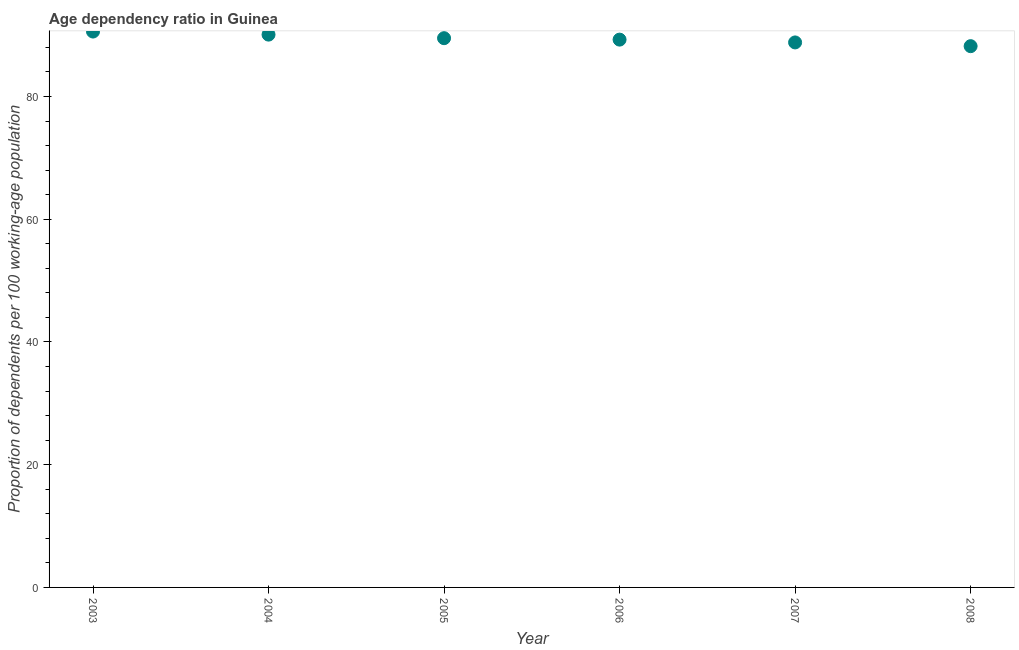What is the age dependency ratio in 2008?
Your response must be concise. 88.2. Across all years, what is the maximum age dependency ratio?
Your response must be concise. 90.58. Across all years, what is the minimum age dependency ratio?
Give a very brief answer. 88.2. What is the sum of the age dependency ratio?
Your answer should be very brief. 536.46. What is the difference between the age dependency ratio in 2007 and 2008?
Offer a very short reply. 0.61. What is the average age dependency ratio per year?
Offer a very short reply. 89.41. What is the median age dependency ratio?
Keep it short and to the point. 89.39. Do a majority of the years between 2007 and 2004 (inclusive) have age dependency ratio greater than 44 ?
Your response must be concise. Yes. What is the ratio of the age dependency ratio in 2003 to that in 2007?
Keep it short and to the point. 1.02. Is the difference between the age dependency ratio in 2003 and 2008 greater than the difference between any two years?
Offer a terse response. Yes. What is the difference between the highest and the second highest age dependency ratio?
Keep it short and to the point. 0.5. Is the sum of the age dependency ratio in 2005 and 2008 greater than the maximum age dependency ratio across all years?
Provide a short and direct response. Yes. What is the difference between the highest and the lowest age dependency ratio?
Your answer should be compact. 2.38. Does the age dependency ratio monotonically increase over the years?
Offer a terse response. No. How many years are there in the graph?
Keep it short and to the point. 6. Are the values on the major ticks of Y-axis written in scientific E-notation?
Provide a succinct answer. No. Does the graph contain grids?
Ensure brevity in your answer.  No. What is the title of the graph?
Make the answer very short. Age dependency ratio in Guinea. What is the label or title of the Y-axis?
Provide a short and direct response. Proportion of dependents per 100 working-age population. What is the Proportion of dependents per 100 working-age population in 2003?
Provide a succinct answer. 90.58. What is the Proportion of dependents per 100 working-age population in 2004?
Provide a short and direct response. 90.08. What is the Proportion of dependents per 100 working-age population in 2005?
Offer a terse response. 89.5. What is the Proportion of dependents per 100 working-age population in 2006?
Your answer should be compact. 89.27. What is the Proportion of dependents per 100 working-age population in 2007?
Offer a very short reply. 88.81. What is the Proportion of dependents per 100 working-age population in 2008?
Offer a very short reply. 88.2. What is the difference between the Proportion of dependents per 100 working-age population in 2003 and 2004?
Your answer should be very brief. 0.5. What is the difference between the Proportion of dependents per 100 working-age population in 2003 and 2005?
Your response must be concise. 1.08. What is the difference between the Proportion of dependents per 100 working-age population in 2003 and 2006?
Your answer should be very brief. 1.31. What is the difference between the Proportion of dependents per 100 working-age population in 2003 and 2007?
Give a very brief answer. 1.77. What is the difference between the Proportion of dependents per 100 working-age population in 2003 and 2008?
Offer a very short reply. 2.38. What is the difference between the Proportion of dependents per 100 working-age population in 2004 and 2005?
Provide a short and direct response. 0.58. What is the difference between the Proportion of dependents per 100 working-age population in 2004 and 2006?
Keep it short and to the point. 0.81. What is the difference between the Proportion of dependents per 100 working-age population in 2004 and 2007?
Keep it short and to the point. 1.27. What is the difference between the Proportion of dependents per 100 working-age population in 2004 and 2008?
Offer a terse response. 1.88. What is the difference between the Proportion of dependents per 100 working-age population in 2005 and 2006?
Offer a very short reply. 0.23. What is the difference between the Proportion of dependents per 100 working-age population in 2005 and 2007?
Your response must be concise. 0.69. What is the difference between the Proportion of dependents per 100 working-age population in 2005 and 2008?
Give a very brief answer. 1.3. What is the difference between the Proportion of dependents per 100 working-age population in 2006 and 2007?
Offer a very short reply. 0.46. What is the difference between the Proportion of dependents per 100 working-age population in 2006 and 2008?
Keep it short and to the point. 1.07. What is the difference between the Proportion of dependents per 100 working-age population in 2007 and 2008?
Provide a short and direct response. 0.61. What is the ratio of the Proportion of dependents per 100 working-age population in 2003 to that in 2004?
Offer a terse response. 1.01. What is the ratio of the Proportion of dependents per 100 working-age population in 2003 to that in 2005?
Your answer should be very brief. 1.01. What is the ratio of the Proportion of dependents per 100 working-age population in 2004 to that in 2006?
Provide a short and direct response. 1.01. 